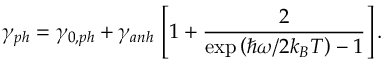Convert formula to latex. <formula><loc_0><loc_0><loc_500><loc_500>\gamma _ { p h } = \gamma _ { 0 , p h } + \gamma _ { a n h } \, \left [ 1 + \frac { 2 } { \exp \left ( \hbar { \omega } / 2 k _ { B } T \right ) - 1 } \right ] .</formula> 